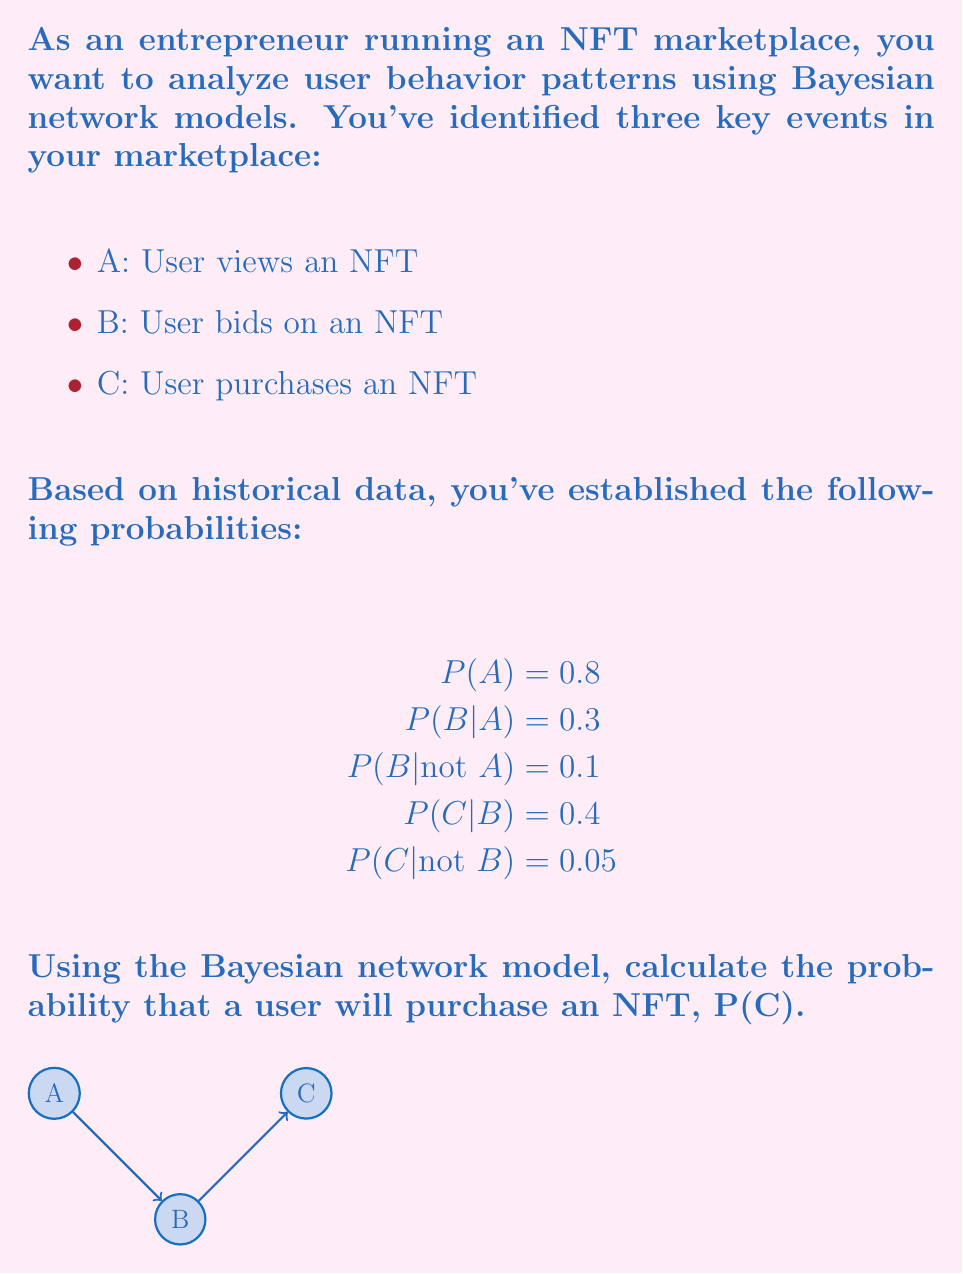Can you answer this question? To solve this problem, we'll use the law of total probability and the Bayesian network structure. Let's break it down step by step:

1) First, we need to calculate P(B) using the law of total probability:
   $$P(B) = P(B|A)P(A) + P(B|not A)P(not A)$$

2) We know P(A) = 0.8, so P(not A) = 1 - 0.8 = 0.2
   $$P(B) = 0.3 * 0.8 + 0.1 * 0.2 = 0.24 + 0.02 = 0.26$$

3) Now we can calculate P(C) using the law of total probability again:
   $$P(C) = P(C|B)P(B) + P(C|not B)P(not B)$$

4) We know P(B) = 0.26, so P(not B) = 1 - 0.26 = 0.74

5) Plugging in the values:
   $$P(C) = 0.4 * 0.26 + 0.05 * 0.74$$

6) Calculating:
   $$P(C) = 0.104 + 0.037 = 0.141$$

Therefore, the probability that a user will purchase an NFT is 0.141 or 14.1%.
Answer: 0.141 